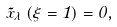Convert formula to latex. <formula><loc_0><loc_0><loc_500><loc_500>\tilde { x } _ { \lambda } \left ( \xi = 1 \right ) = 0 ,</formula> 